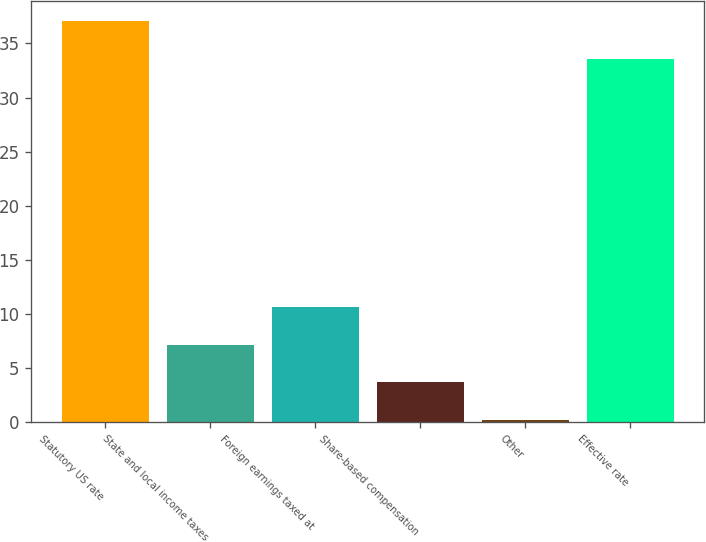Convert chart to OTSL. <chart><loc_0><loc_0><loc_500><loc_500><bar_chart><fcel>Statutory US rate<fcel>State and local income taxes<fcel>Foreign earnings taxed at<fcel>Share-based compensation<fcel>Other<fcel>Effective rate<nl><fcel>37.08<fcel>7.16<fcel>10.64<fcel>3.68<fcel>0.2<fcel>33.6<nl></chart> 